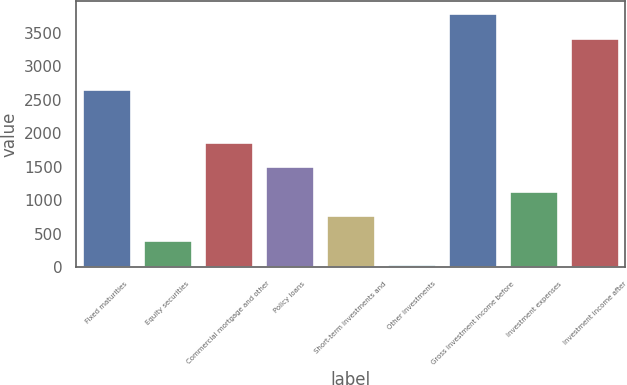Convert chart to OTSL. <chart><loc_0><loc_0><loc_500><loc_500><bar_chart><fcel>Fixed maturities<fcel>Equity securities<fcel>Commercial mortgage and other<fcel>Policy loans<fcel>Short-term investments and<fcel>Other investments<fcel>Gross investment income before<fcel>Investment expenses<fcel>Investment income after<nl><fcel>2664<fcel>409.5<fcel>1871.5<fcel>1506<fcel>775<fcel>44<fcel>3786.5<fcel>1140.5<fcel>3421<nl></chart> 